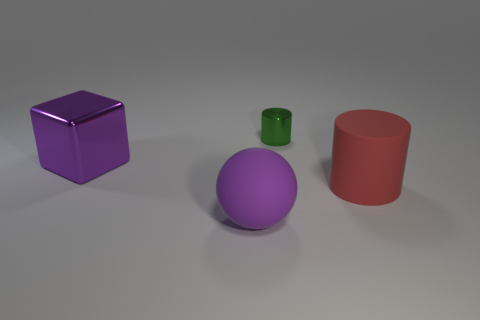Add 2 large purple rubber things. How many objects exist? 6 Subtract 1 spheres. How many spheres are left? 0 Subtract all green cylinders. How many cylinders are left? 1 Add 1 tiny green metal things. How many tiny green metal things are left? 2 Add 2 big red rubber objects. How many big red rubber objects exist? 3 Subtract 0 blue blocks. How many objects are left? 4 Subtract all blocks. How many objects are left? 3 Subtract all brown cylinders. Subtract all yellow spheres. How many cylinders are left? 2 Subtract all gray balls. How many green cylinders are left? 1 Subtract all big spheres. Subtract all metallic things. How many objects are left? 1 